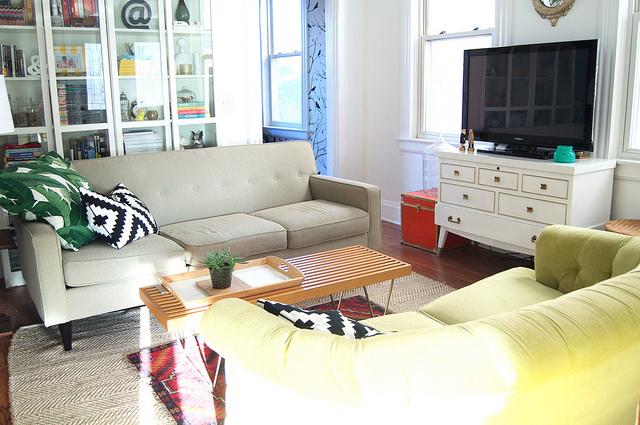How many pillows on the beige couch?
Concise answer only. 2. Is this a living area?
Give a very brief answer. Yes. How many windows are in the picture?
Answer briefly. 3. Is there a rosemary plant on the tray?
Keep it brief. Yes. 